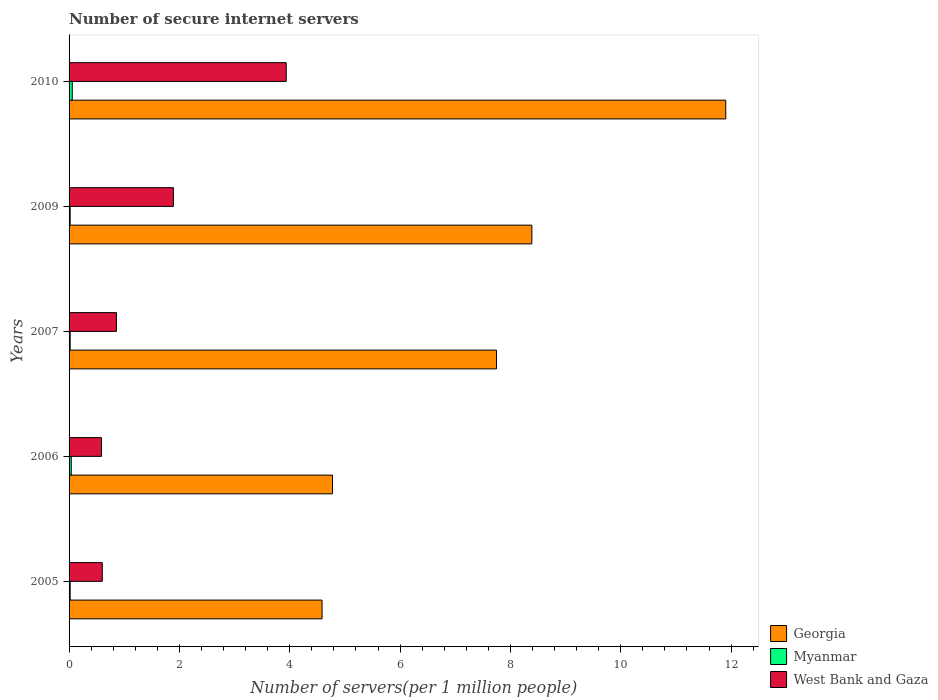How many different coloured bars are there?
Your answer should be very brief. 3. How many groups of bars are there?
Your answer should be compact. 5. How many bars are there on the 1st tick from the bottom?
Provide a short and direct response. 3. In how many cases, is the number of bars for a given year not equal to the number of legend labels?
Give a very brief answer. 0. What is the number of secure internet servers in West Bank and Gaza in 2005?
Make the answer very short. 0.6. Across all years, what is the maximum number of secure internet servers in Myanmar?
Offer a terse response. 0.06. Across all years, what is the minimum number of secure internet servers in West Bank and Gaza?
Your answer should be compact. 0.59. In which year was the number of secure internet servers in Georgia minimum?
Offer a very short reply. 2005. What is the total number of secure internet servers in West Bank and Gaza in the graph?
Your response must be concise. 7.87. What is the difference between the number of secure internet servers in Georgia in 2006 and that in 2007?
Your response must be concise. -2.97. What is the difference between the number of secure internet servers in West Bank and Gaza in 2006 and the number of secure internet servers in Myanmar in 2007?
Your response must be concise. 0.57. What is the average number of secure internet servers in West Bank and Gaza per year?
Provide a succinct answer. 1.57. In the year 2005, what is the difference between the number of secure internet servers in Georgia and number of secure internet servers in Myanmar?
Your answer should be very brief. 4.57. In how many years, is the number of secure internet servers in Myanmar greater than 9.2 ?
Provide a short and direct response. 0. What is the ratio of the number of secure internet servers in Georgia in 2005 to that in 2009?
Ensure brevity in your answer.  0.55. Is the number of secure internet servers in Myanmar in 2005 less than that in 2010?
Provide a short and direct response. Yes. Is the difference between the number of secure internet servers in Georgia in 2005 and 2009 greater than the difference between the number of secure internet servers in Myanmar in 2005 and 2009?
Provide a succinct answer. No. What is the difference between the highest and the second highest number of secure internet servers in Georgia?
Ensure brevity in your answer.  3.51. What is the difference between the highest and the lowest number of secure internet servers in West Bank and Gaza?
Your answer should be compact. 3.35. Is the sum of the number of secure internet servers in West Bank and Gaza in 2006 and 2009 greater than the maximum number of secure internet servers in Georgia across all years?
Make the answer very short. No. What does the 3rd bar from the top in 2010 represents?
Provide a succinct answer. Georgia. What does the 2nd bar from the bottom in 2007 represents?
Make the answer very short. Myanmar. Are all the bars in the graph horizontal?
Offer a terse response. Yes. Are the values on the major ticks of X-axis written in scientific E-notation?
Make the answer very short. No. Does the graph contain grids?
Provide a succinct answer. No. Where does the legend appear in the graph?
Offer a terse response. Bottom right. How many legend labels are there?
Your response must be concise. 3. What is the title of the graph?
Your answer should be compact. Number of secure internet servers. What is the label or title of the X-axis?
Keep it short and to the point. Number of servers(per 1 million people). What is the Number of servers(per 1 million people) of Georgia in 2005?
Offer a terse response. 4.59. What is the Number of servers(per 1 million people) in Myanmar in 2005?
Ensure brevity in your answer.  0.02. What is the Number of servers(per 1 million people) of West Bank and Gaza in 2005?
Provide a short and direct response. 0.6. What is the Number of servers(per 1 million people) of Georgia in 2006?
Keep it short and to the point. 4.77. What is the Number of servers(per 1 million people) in Myanmar in 2006?
Your answer should be very brief. 0.04. What is the Number of servers(per 1 million people) in West Bank and Gaza in 2006?
Your answer should be compact. 0.59. What is the Number of servers(per 1 million people) in Georgia in 2007?
Ensure brevity in your answer.  7.75. What is the Number of servers(per 1 million people) of Myanmar in 2007?
Keep it short and to the point. 0.02. What is the Number of servers(per 1 million people) in West Bank and Gaza in 2007?
Provide a succinct answer. 0.86. What is the Number of servers(per 1 million people) of Georgia in 2009?
Provide a succinct answer. 8.39. What is the Number of servers(per 1 million people) of Myanmar in 2009?
Make the answer very short. 0.02. What is the Number of servers(per 1 million people) in West Bank and Gaza in 2009?
Provide a short and direct response. 1.89. What is the Number of servers(per 1 million people) of Georgia in 2010?
Keep it short and to the point. 11.9. What is the Number of servers(per 1 million people) in Myanmar in 2010?
Offer a terse response. 0.06. What is the Number of servers(per 1 million people) of West Bank and Gaza in 2010?
Keep it short and to the point. 3.94. Across all years, what is the maximum Number of servers(per 1 million people) in Georgia?
Keep it short and to the point. 11.9. Across all years, what is the maximum Number of servers(per 1 million people) of Myanmar?
Keep it short and to the point. 0.06. Across all years, what is the maximum Number of servers(per 1 million people) of West Bank and Gaza?
Make the answer very short. 3.94. Across all years, what is the minimum Number of servers(per 1 million people) in Georgia?
Your answer should be very brief. 4.59. Across all years, what is the minimum Number of servers(per 1 million people) of Myanmar?
Provide a succinct answer. 0.02. Across all years, what is the minimum Number of servers(per 1 million people) of West Bank and Gaza?
Keep it short and to the point. 0.59. What is the total Number of servers(per 1 million people) of Georgia in the graph?
Offer a very short reply. 37.4. What is the total Number of servers(per 1 million people) in Myanmar in the graph?
Make the answer very short. 0.16. What is the total Number of servers(per 1 million people) of West Bank and Gaza in the graph?
Your response must be concise. 7.87. What is the difference between the Number of servers(per 1 million people) of Georgia in 2005 and that in 2006?
Give a very brief answer. -0.19. What is the difference between the Number of servers(per 1 million people) in Myanmar in 2005 and that in 2006?
Your answer should be very brief. -0.02. What is the difference between the Number of servers(per 1 million people) in West Bank and Gaza in 2005 and that in 2006?
Provide a succinct answer. 0.02. What is the difference between the Number of servers(per 1 million people) in Georgia in 2005 and that in 2007?
Offer a terse response. -3.16. What is the difference between the Number of servers(per 1 million people) in West Bank and Gaza in 2005 and that in 2007?
Your response must be concise. -0.26. What is the difference between the Number of servers(per 1 million people) in Georgia in 2005 and that in 2009?
Provide a succinct answer. -3.8. What is the difference between the Number of servers(per 1 million people) of Myanmar in 2005 and that in 2009?
Ensure brevity in your answer.  0. What is the difference between the Number of servers(per 1 million people) in West Bank and Gaza in 2005 and that in 2009?
Your answer should be very brief. -1.29. What is the difference between the Number of servers(per 1 million people) of Georgia in 2005 and that in 2010?
Provide a succinct answer. -7.32. What is the difference between the Number of servers(per 1 million people) in Myanmar in 2005 and that in 2010?
Your answer should be compact. -0.04. What is the difference between the Number of servers(per 1 million people) in West Bank and Gaza in 2005 and that in 2010?
Your response must be concise. -3.33. What is the difference between the Number of servers(per 1 million people) of Georgia in 2006 and that in 2007?
Offer a terse response. -2.97. What is the difference between the Number of servers(per 1 million people) of Myanmar in 2006 and that in 2007?
Give a very brief answer. 0.02. What is the difference between the Number of servers(per 1 million people) of West Bank and Gaza in 2006 and that in 2007?
Your answer should be very brief. -0.27. What is the difference between the Number of servers(per 1 million people) in Georgia in 2006 and that in 2009?
Offer a terse response. -3.61. What is the difference between the Number of servers(per 1 million people) of Myanmar in 2006 and that in 2009?
Provide a short and direct response. 0.02. What is the difference between the Number of servers(per 1 million people) in West Bank and Gaza in 2006 and that in 2009?
Provide a short and direct response. -1.3. What is the difference between the Number of servers(per 1 million people) in Georgia in 2006 and that in 2010?
Make the answer very short. -7.13. What is the difference between the Number of servers(per 1 million people) in Myanmar in 2006 and that in 2010?
Keep it short and to the point. -0.02. What is the difference between the Number of servers(per 1 million people) of West Bank and Gaza in 2006 and that in 2010?
Offer a terse response. -3.35. What is the difference between the Number of servers(per 1 million people) in Georgia in 2007 and that in 2009?
Provide a succinct answer. -0.64. What is the difference between the Number of servers(per 1 million people) of West Bank and Gaza in 2007 and that in 2009?
Offer a terse response. -1.03. What is the difference between the Number of servers(per 1 million people) of Georgia in 2007 and that in 2010?
Keep it short and to the point. -4.15. What is the difference between the Number of servers(per 1 million people) of Myanmar in 2007 and that in 2010?
Give a very brief answer. -0.04. What is the difference between the Number of servers(per 1 million people) in West Bank and Gaza in 2007 and that in 2010?
Provide a short and direct response. -3.08. What is the difference between the Number of servers(per 1 million people) in Georgia in 2009 and that in 2010?
Ensure brevity in your answer.  -3.51. What is the difference between the Number of servers(per 1 million people) in Myanmar in 2009 and that in 2010?
Keep it short and to the point. -0.04. What is the difference between the Number of servers(per 1 million people) in West Bank and Gaza in 2009 and that in 2010?
Give a very brief answer. -2.05. What is the difference between the Number of servers(per 1 million people) in Georgia in 2005 and the Number of servers(per 1 million people) in Myanmar in 2006?
Make the answer very short. 4.55. What is the difference between the Number of servers(per 1 million people) in Georgia in 2005 and the Number of servers(per 1 million people) in West Bank and Gaza in 2006?
Your response must be concise. 4. What is the difference between the Number of servers(per 1 million people) of Myanmar in 2005 and the Number of servers(per 1 million people) of West Bank and Gaza in 2006?
Give a very brief answer. -0.57. What is the difference between the Number of servers(per 1 million people) in Georgia in 2005 and the Number of servers(per 1 million people) in Myanmar in 2007?
Your answer should be very brief. 4.57. What is the difference between the Number of servers(per 1 million people) of Georgia in 2005 and the Number of servers(per 1 million people) of West Bank and Gaza in 2007?
Keep it short and to the point. 3.73. What is the difference between the Number of servers(per 1 million people) in Myanmar in 2005 and the Number of servers(per 1 million people) in West Bank and Gaza in 2007?
Ensure brevity in your answer.  -0.84. What is the difference between the Number of servers(per 1 million people) in Georgia in 2005 and the Number of servers(per 1 million people) in Myanmar in 2009?
Keep it short and to the point. 4.57. What is the difference between the Number of servers(per 1 million people) in Georgia in 2005 and the Number of servers(per 1 million people) in West Bank and Gaza in 2009?
Provide a short and direct response. 2.69. What is the difference between the Number of servers(per 1 million people) in Myanmar in 2005 and the Number of servers(per 1 million people) in West Bank and Gaza in 2009?
Offer a terse response. -1.87. What is the difference between the Number of servers(per 1 million people) of Georgia in 2005 and the Number of servers(per 1 million people) of Myanmar in 2010?
Your answer should be compact. 4.53. What is the difference between the Number of servers(per 1 million people) in Georgia in 2005 and the Number of servers(per 1 million people) in West Bank and Gaza in 2010?
Keep it short and to the point. 0.65. What is the difference between the Number of servers(per 1 million people) in Myanmar in 2005 and the Number of servers(per 1 million people) in West Bank and Gaza in 2010?
Your answer should be compact. -3.92. What is the difference between the Number of servers(per 1 million people) in Georgia in 2006 and the Number of servers(per 1 million people) in Myanmar in 2007?
Your answer should be compact. 4.76. What is the difference between the Number of servers(per 1 million people) of Georgia in 2006 and the Number of servers(per 1 million people) of West Bank and Gaza in 2007?
Your answer should be very brief. 3.92. What is the difference between the Number of servers(per 1 million people) of Myanmar in 2006 and the Number of servers(per 1 million people) of West Bank and Gaza in 2007?
Provide a short and direct response. -0.82. What is the difference between the Number of servers(per 1 million people) of Georgia in 2006 and the Number of servers(per 1 million people) of Myanmar in 2009?
Ensure brevity in your answer.  4.76. What is the difference between the Number of servers(per 1 million people) of Georgia in 2006 and the Number of servers(per 1 million people) of West Bank and Gaza in 2009?
Your answer should be compact. 2.88. What is the difference between the Number of servers(per 1 million people) of Myanmar in 2006 and the Number of servers(per 1 million people) of West Bank and Gaza in 2009?
Your response must be concise. -1.85. What is the difference between the Number of servers(per 1 million people) in Georgia in 2006 and the Number of servers(per 1 million people) in Myanmar in 2010?
Your answer should be very brief. 4.72. What is the difference between the Number of servers(per 1 million people) of Georgia in 2006 and the Number of servers(per 1 million people) of West Bank and Gaza in 2010?
Ensure brevity in your answer.  0.84. What is the difference between the Number of servers(per 1 million people) of Myanmar in 2006 and the Number of servers(per 1 million people) of West Bank and Gaza in 2010?
Offer a very short reply. -3.9. What is the difference between the Number of servers(per 1 million people) of Georgia in 2007 and the Number of servers(per 1 million people) of Myanmar in 2009?
Provide a succinct answer. 7.73. What is the difference between the Number of servers(per 1 million people) of Georgia in 2007 and the Number of servers(per 1 million people) of West Bank and Gaza in 2009?
Provide a short and direct response. 5.86. What is the difference between the Number of servers(per 1 million people) of Myanmar in 2007 and the Number of servers(per 1 million people) of West Bank and Gaza in 2009?
Offer a terse response. -1.87. What is the difference between the Number of servers(per 1 million people) of Georgia in 2007 and the Number of servers(per 1 million people) of Myanmar in 2010?
Offer a terse response. 7.69. What is the difference between the Number of servers(per 1 million people) of Georgia in 2007 and the Number of servers(per 1 million people) of West Bank and Gaza in 2010?
Give a very brief answer. 3.81. What is the difference between the Number of servers(per 1 million people) of Myanmar in 2007 and the Number of servers(per 1 million people) of West Bank and Gaza in 2010?
Offer a very short reply. -3.92. What is the difference between the Number of servers(per 1 million people) of Georgia in 2009 and the Number of servers(per 1 million people) of Myanmar in 2010?
Your response must be concise. 8.33. What is the difference between the Number of servers(per 1 million people) in Georgia in 2009 and the Number of servers(per 1 million people) in West Bank and Gaza in 2010?
Provide a short and direct response. 4.45. What is the difference between the Number of servers(per 1 million people) in Myanmar in 2009 and the Number of servers(per 1 million people) in West Bank and Gaza in 2010?
Offer a very short reply. -3.92. What is the average Number of servers(per 1 million people) in Georgia per year?
Your response must be concise. 7.48. What is the average Number of servers(per 1 million people) in Myanmar per year?
Make the answer very short. 0.03. What is the average Number of servers(per 1 million people) of West Bank and Gaza per year?
Provide a short and direct response. 1.57. In the year 2005, what is the difference between the Number of servers(per 1 million people) in Georgia and Number of servers(per 1 million people) in Myanmar?
Provide a succinct answer. 4.57. In the year 2005, what is the difference between the Number of servers(per 1 million people) of Georgia and Number of servers(per 1 million people) of West Bank and Gaza?
Your answer should be compact. 3.98. In the year 2005, what is the difference between the Number of servers(per 1 million people) of Myanmar and Number of servers(per 1 million people) of West Bank and Gaza?
Your answer should be compact. -0.58. In the year 2006, what is the difference between the Number of servers(per 1 million people) in Georgia and Number of servers(per 1 million people) in Myanmar?
Provide a short and direct response. 4.74. In the year 2006, what is the difference between the Number of servers(per 1 million people) of Georgia and Number of servers(per 1 million people) of West Bank and Gaza?
Make the answer very short. 4.19. In the year 2006, what is the difference between the Number of servers(per 1 million people) of Myanmar and Number of servers(per 1 million people) of West Bank and Gaza?
Your answer should be very brief. -0.55. In the year 2007, what is the difference between the Number of servers(per 1 million people) in Georgia and Number of servers(per 1 million people) in Myanmar?
Give a very brief answer. 7.73. In the year 2007, what is the difference between the Number of servers(per 1 million people) in Georgia and Number of servers(per 1 million people) in West Bank and Gaza?
Provide a succinct answer. 6.89. In the year 2007, what is the difference between the Number of servers(per 1 million people) in Myanmar and Number of servers(per 1 million people) in West Bank and Gaza?
Ensure brevity in your answer.  -0.84. In the year 2009, what is the difference between the Number of servers(per 1 million people) in Georgia and Number of servers(per 1 million people) in Myanmar?
Give a very brief answer. 8.37. In the year 2009, what is the difference between the Number of servers(per 1 million people) of Georgia and Number of servers(per 1 million people) of West Bank and Gaza?
Keep it short and to the point. 6.5. In the year 2009, what is the difference between the Number of servers(per 1 million people) of Myanmar and Number of servers(per 1 million people) of West Bank and Gaza?
Your answer should be compact. -1.87. In the year 2010, what is the difference between the Number of servers(per 1 million people) of Georgia and Number of servers(per 1 million people) of Myanmar?
Provide a succinct answer. 11.84. In the year 2010, what is the difference between the Number of servers(per 1 million people) in Georgia and Number of servers(per 1 million people) in West Bank and Gaza?
Offer a terse response. 7.97. In the year 2010, what is the difference between the Number of servers(per 1 million people) of Myanmar and Number of servers(per 1 million people) of West Bank and Gaza?
Keep it short and to the point. -3.88. What is the ratio of the Number of servers(per 1 million people) of Georgia in 2005 to that in 2006?
Keep it short and to the point. 0.96. What is the ratio of the Number of servers(per 1 million people) of Myanmar in 2005 to that in 2006?
Offer a very short reply. 0.5. What is the ratio of the Number of servers(per 1 million people) in West Bank and Gaza in 2005 to that in 2006?
Your response must be concise. 1.03. What is the ratio of the Number of servers(per 1 million people) of Georgia in 2005 to that in 2007?
Keep it short and to the point. 0.59. What is the ratio of the Number of servers(per 1 million people) of Myanmar in 2005 to that in 2007?
Make the answer very short. 1.01. What is the ratio of the Number of servers(per 1 million people) in West Bank and Gaza in 2005 to that in 2007?
Offer a terse response. 0.7. What is the ratio of the Number of servers(per 1 million people) of Georgia in 2005 to that in 2009?
Make the answer very short. 0.55. What is the ratio of the Number of servers(per 1 million people) of Myanmar in 2005 to that in 2009?
Your answer should be compact. 1.03. What is the ratio of the Number of servers(per 1 million people) in West Bank and Gaza in 2005 to that in 2009?
Make the answer very short. 0.32. What is the ratio of the Number of servers(per 1 million people) in Georgia in 2005 to that in 2010?
Ensure brevity in your answer.  0.39. What is the ratio of the Number of servers(per 1 million people) in Myanmar in 2005 to that in 2010?
Your answer should be very brief. 0.34. What is the ratio of the Number of servers(per 1 million people) of West Bank and Gaza in 2005 to that in 2010?
Give a very brief answer. 0.15. What is the ratio of the Number of servers(per 1 million people) of Georgia in 2006 to that in 2007?
Provide a succinct answer. 0.62. What is the ratio of the Number of servers(per 1 million people) of Myanmar in 2006 to that in 2007?
Keep it short and to the point. 2.01. What is the ratio of the Number of servers(per 1 million people) in West Bank and Gaza in 2006 to that in 2007?
Make the answer very short. 0.68. What is the ratio of the Number of servers(per 1 million people) in Georgia in 2006 to that in 2009?
Offer a terse response. 0.57. What is the ratio of the Number of servers(per 1 million people) in Myanmar in 2006 to that in 2009?
Your response must be concise. 2.04. What is the ratio of the Number of servers(per 1 million people) in West Bank and Gaza in 2006 to that in 2009?
Your answer should be compact. 0.31. What is the ratio of the Number of servers(per 1 million people) of Georgia in 2006 to that in 2010?
Your answer should be very brief. 0.4. What is the ratio of the Number of servers(per 1 million people) in Myanmar in 2006 to that in 2010?
Your response must be concise. 0.68. What is the ratio of the Number of servers(per 1 million people) in West Bank and Gaza in 2006 to that in 2010?
Offer a terse response. 0.15. What is the ratio of the Number of servers(per 1 million people) in Georgia in 2007 to that in 2009?
Provide a short and direct response. 0.92. What is the ratio of the Number of servers(per 1 million people) of Myanmar in 2007 to that in 2009?
Provide a short and direct response. 1.01. What is the ratio of the Number of servers(per 1 million people) in West Bank and Gaza in 2007 to that in 2009?
Make the answer very short. 0.45. What is the ratio of the Number of servers(per 1 million people) in Georgia in 2007 to that in 2010?
Provide a succinct answer. 0.65. What is the ratio of the Number of servers(per 1 million people) in Myanmar in 2007 to that in 2010?
Provide a short and direct response. 0.34. What is the ratio of the Number of servers(per 1 million people) in West Bank and Gaza in 2007 to that in 2010?
Provide a short and direct response. 0.22. What is the ratio of the Number of servers(per 1 million people) of Georgia in 2009 to that in 2010?
Provide a succinct answer. 0.7. What is the ratio of the Number of servers(per 1 million people) in Myanmar in 2009 to that in 2010?
Keep it short and to the point. 0.34. What is the ratio of the Number of servers(per 1 million people) in West Bank and Gaza in 2009 to that in 2010?
Provide a succinct answer. 0.48. What is the difference between the highest and the second highest Number of servers(per 1 million people) in Georgia?
Your answer should be very brief. 3.51. What is the difference between the highest and the second highest Number of servers(per 1 million people) in Myanmar?
Make the answer very short. 0.02. What is the difference between the highest and the second highest Number of servers(per 1 million people) of West Bank and Gaza?
Ensure brevity in your answer.  2.05. What is the difference between the highest and the lowest Number of servers(per 1 million people) in Georgia?
Keep it short and to the point. 7.32. What is the difference between the highest and the lowest Number of servers(per 1 million people) of Myanmar?
Provide a succinct answer. 0.04. What is the difference between the highest and the lowest Number of servers(per 1 million people) of West Bank and Gaza?
Keep it short and to the point. 3.35. 